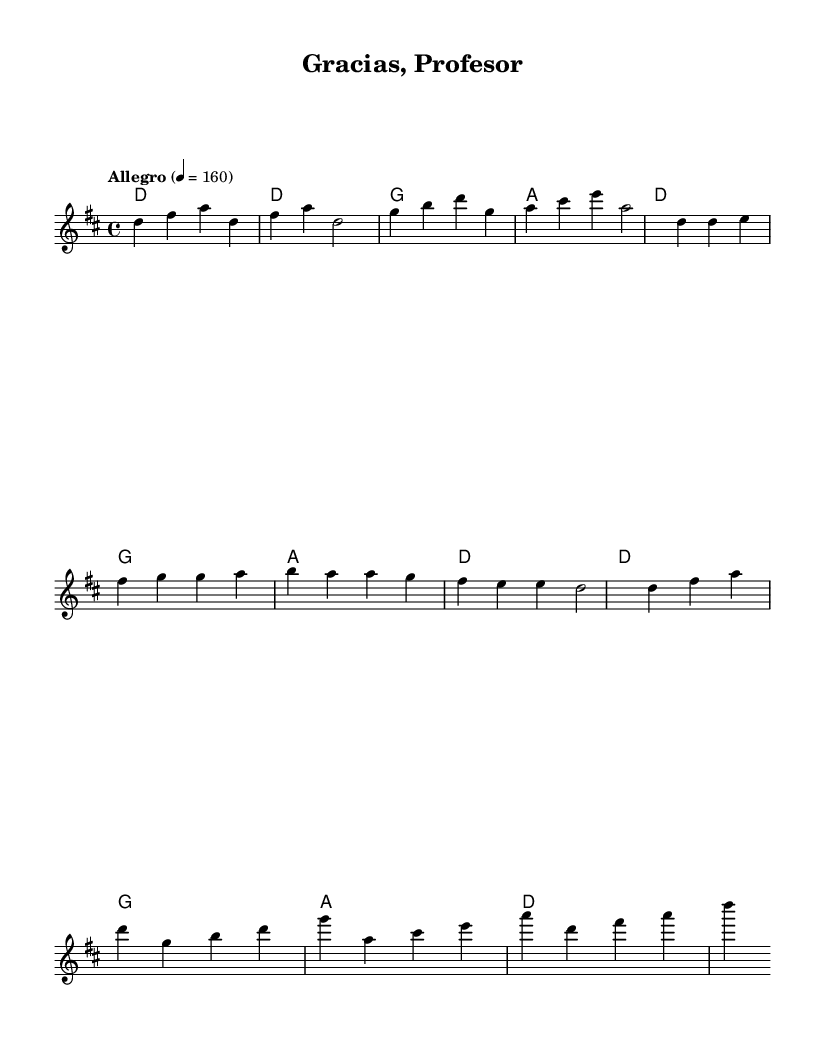What is the key signature of this music? The key signature is indicated in the global musical context section, where it specifies "d major," meaning there are two sharps: F# and C#.
Answer: d major What is the time signature of this music? The time signature is found in the global section as "4/4," which means there are four beats in each measure, and the quarter note gets one beat.
Answer: 4/4 What is the tempo marking of this piece? The tempo marking in the global section reads "Allegro" with a metronome marking of quarter note equals 160, indicating a fast pace.
Answer: Allegro How many bars are in the chorus? The chorus section, as marked, consists of four measures in total, making it concise and straightforward.
Answer: Four Which phrase in the lyrics expresses gratitude? In the chorus lyrics, the phrases "¡Gra -- cias, pro -- fe -- sor!" distinctly express gratitude towards the professor, celebrating their support and guidance.
Answer: ¡Gra -- cias, pro -- fe -- sor! What is the highest pitch note in the melody? By analyzing the melody line, the highest pitch note is Csharp, as it appears in the measure corresponding to the chorus section.
Answer: Csharp Which chord follows the introductory measures of the music? The introductory section consists of four measures where the first chord is D major, followed by G and A major, thus confirming the progression.
Answer: D major 